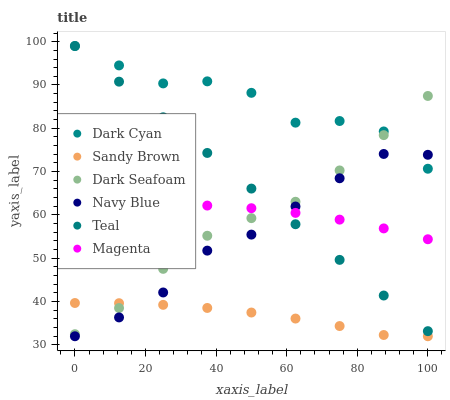Does Sandy Brown have the minimum area under the curve?
Answer yes or no. Yes. Does Dark Cyan have the maximum area under the curve?
Answer yes or no. Yes. Does Dark Seafoam have the minimum area under the curve?
Answer yes or no. No. Does Dark Seafoam have the maximum area under the curve?
Answer yes or no. No. Is Teal the smoothest?
Answer yes or no. Yes. Is Dark Cyan the roughest?
Answer yes or no. Yes. Is Dark Seafoam the smoothest?
Answer yes or no. No. Is Dark Seafoam the roughest?
Answer yes or no. No. Does Navy Blue have the lowest value?
Answer yes or no. Yes. Does Dark Seafoam have the lowest value?
Answer yes or no. No. Does Dark Cyan have the highest value?
Answer yes or no. Yes. Does Dark Seafoam have the highest value?
Answer yes or no. No. Is Navy Blue less than Dark Seafoam?
Answer yes or no. Yes. Is Dark Cyan greater than Sandy Brown?
Answer yes or no. Yes. Does Sandy Brown intersect Dark Seafoam?
Answer yes or no. Yes. Is Sandy Brown less than Dark Seafoam?
Answer yes or no. No. Is Sandy Brown greater than Dark Seafoam?
Answer yes or no. No. Does Navy Blue intersect Dark Seafoam?
Answer yes or no. No. 